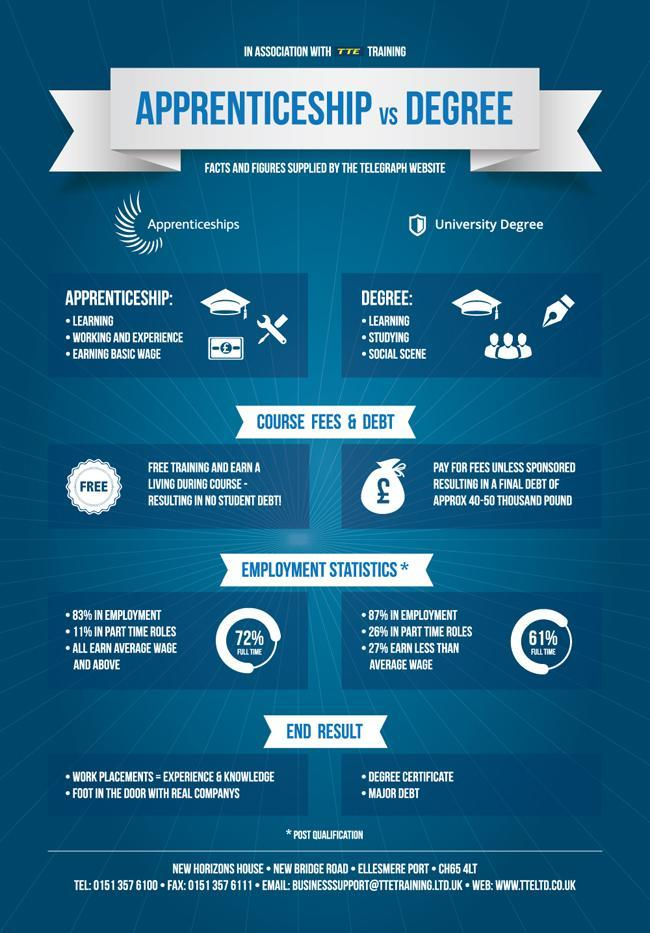Which type of education is most favorable for securing a job?
Answer the question with a short phrase. Apprenticeship Name the type of learning that burdens the student with debt. Degree Name the top qualities that employers look for in prospective employees? Experience, Knowledge Which type of education affords debt-free learning? Apprenticeship What is the percentage of degree holders who earn average wage and above? 73% 